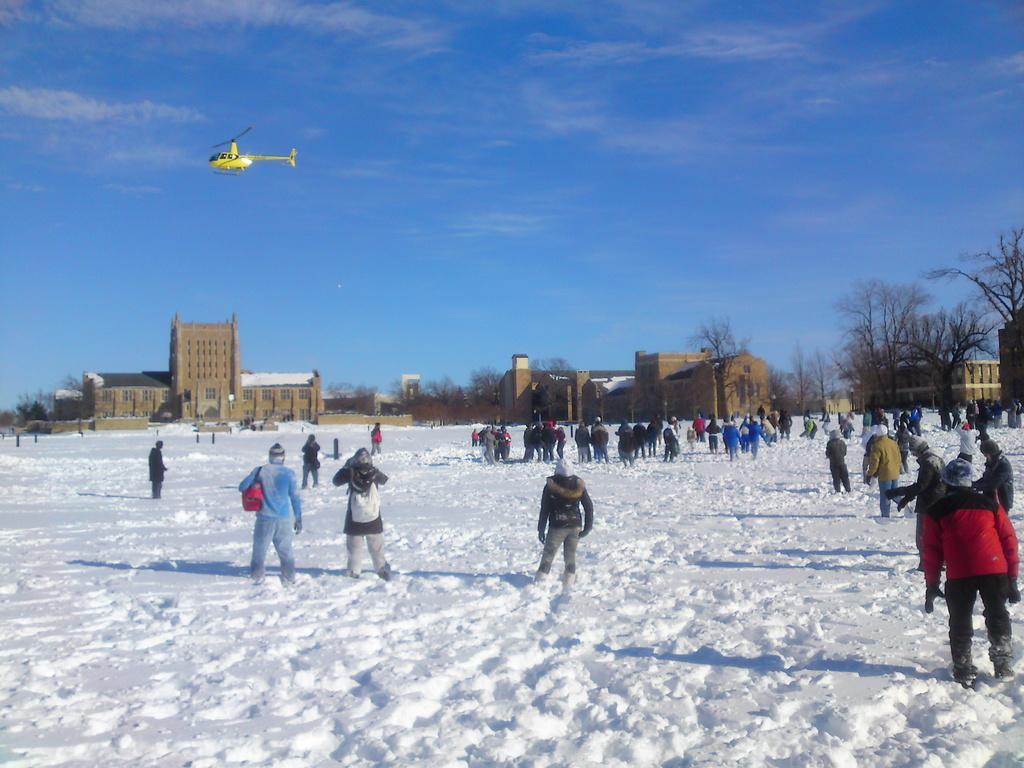Can you describe this image briefly? In this picture we can see a group of people standing on snow, trees, buildings with windows and in the background we can see a helicopter flying in the sky with clouds. 